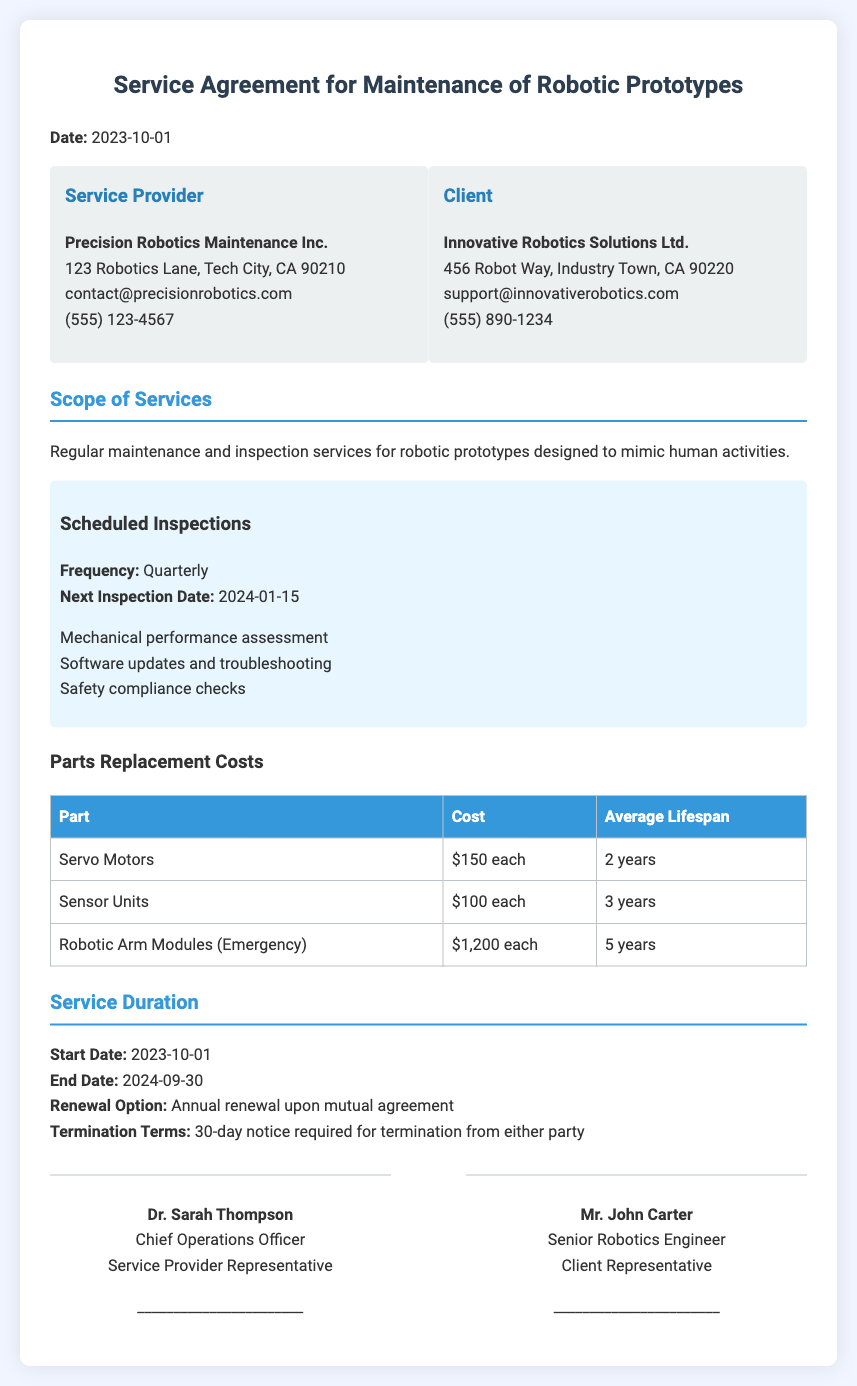What is the date of the service agreement? The date is mentioned at the top of the document as the date of the service agreement.
Answer: 2023-10-01 Who is the service provider? The service provider's name is listed in the party information section.
Answer: Precision Robotics Maintenance Inc What is the next inspection date? The next inspection date is specified in the scheduled inspections section of the document.
Answer: 2024-01-15 What is the cost of servo motors? The cost of servo motors is detailed in the parts replacement costs table.
Answer: $150 each What is the service duration? The service duration is specified by the start and end dates in the document.
Answer: 2023-10-01 to 2024-09-30 How many days notice is required for termination? The termination terms in the document outline the notice period required.
Answer: 30-day notice What is the renewal option stated in the document? The renewal option is mentioned in the service duration section.
Answer: Annual renewal upon mutual agreement What are the average lifespans of sensor units? The average lifespan is provided in the parts replacement costs table.
Answer: 3 years What type of maintenance services are included? The type of services is outlined in the scope of services section.
Answer: Regular maintenance and inspection services 